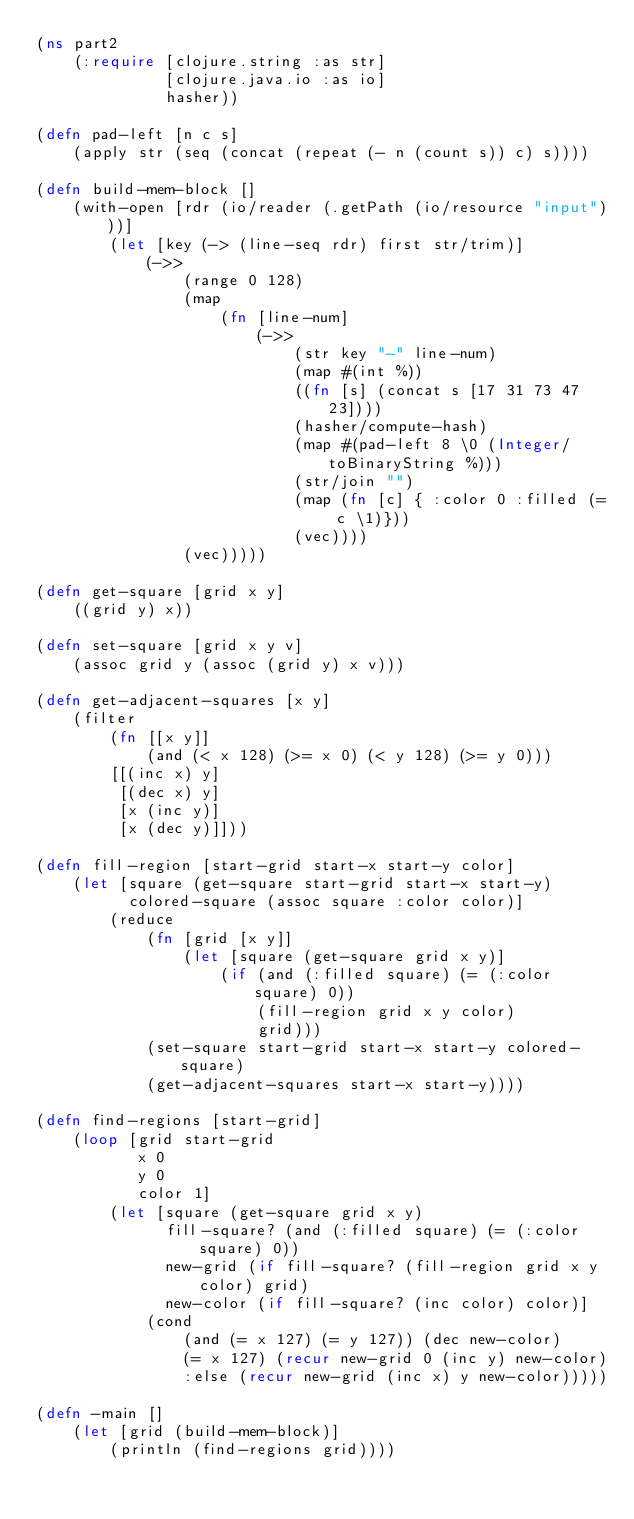<code> <loc_0><loc_0><loc_500><loc_500><_Clojure_>(ns part2
    (:require [clojure.string :as str]
              [clojure.java.io :as io]
              hasher))

(defn pad-left [n c s]
    (apply str (seq (concat (repeat (- n (count s)) c) s))))

(defn build-mem-block []
    (with-open [rdr (io/reader (.getPath (io/resource "input")))]
        (let [key (-> (line-seq rdr) first str/trim)]
            (->>
                (range 0 128)
                (map
                    (fn [line-num]
                        (->>
                            (str key "-" line-num)
                            (map #(int %))
                            ((fn [s] (concat s [17 31 73 47 23])))
                            (hasher/compute-hash)
                            (map #(pad-left 8 \0 (Integer/toBinaryString %)))
                            (str/join "")
                            (map (fn [c] { :color 0 :filled (= c \1)}))
                            (vec))))
                (vec)))))

(defn get-square [grid x y]
    ((grid y) x))

(defn set-square [grid x y v]
    (assoc grid y (assoc (grid y) x v)))

(defn get-adjacent-squares [x y]
    (filter
        (fn [[x y]]
            (and (< x 128) (>= x 0) (< y 128) (>= y 0)))
        [[(inc x) y]
         [(dec x) y]
         [x (inc y)]
         [x (dec y)]]))

(defn fill-region [start-grid start-x start-y color]
    (let [square (get-square start-grid start-x start-y)
          colored-square (assoc square :color color)]
        (reduce
            (fn [grid [x y]]
                (let [square (get-square grid x y)]
                    (if (and (:filled square) (= (:color square) 0))
                        (fill-region grid x y color)
                        grid)))
            (set-square start-grid start-x start-y colored-square)
            (get-adjacent-squares start-x start-y))))

(defn find-regions [start-grid]
    (loop [grid start-grid
           x 0
           y 0
           color 1]
        (let [square (get-square grid x y)
              fill-square? (and (:filled square) (= (:color square) 0))
              new-grid (if fill-square? (fill-region grid x y color) grid)
              new-color (if fill-square? (inc color) color)]
            (cond
                (and (= x 127) (= y 127)) (dec new-color)
                (= x 127) (recur new-grid 0 (inc y) new-color)
                :else (recur new-grid (inc x) y new-color)))))

(defn -main []
    (let [grid (build-mem-block)]
        (println (find-regions grid))))
</code> 